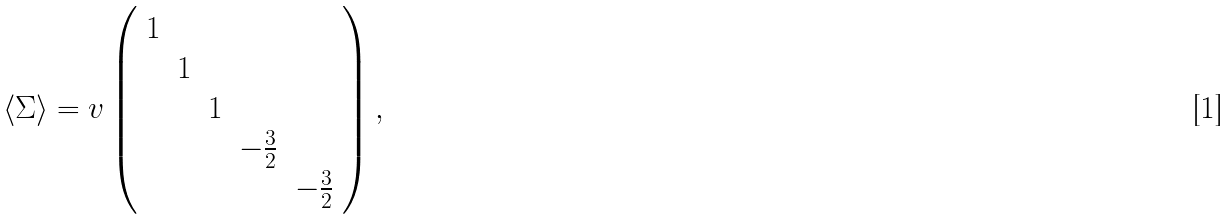Convert formula to latex. <formula><loc_0><loc_0><loc_500><loc_500>\langle \Sigma \rangle = v \left ( \begin{array} { c c c c c } 1 \\ & 1 \\ & & 1 \\ & & & - \frac { 3 } { 2 } \\ & & & & - \frac { 3 } { 2 } \end{array} \right ) ,</formula> 